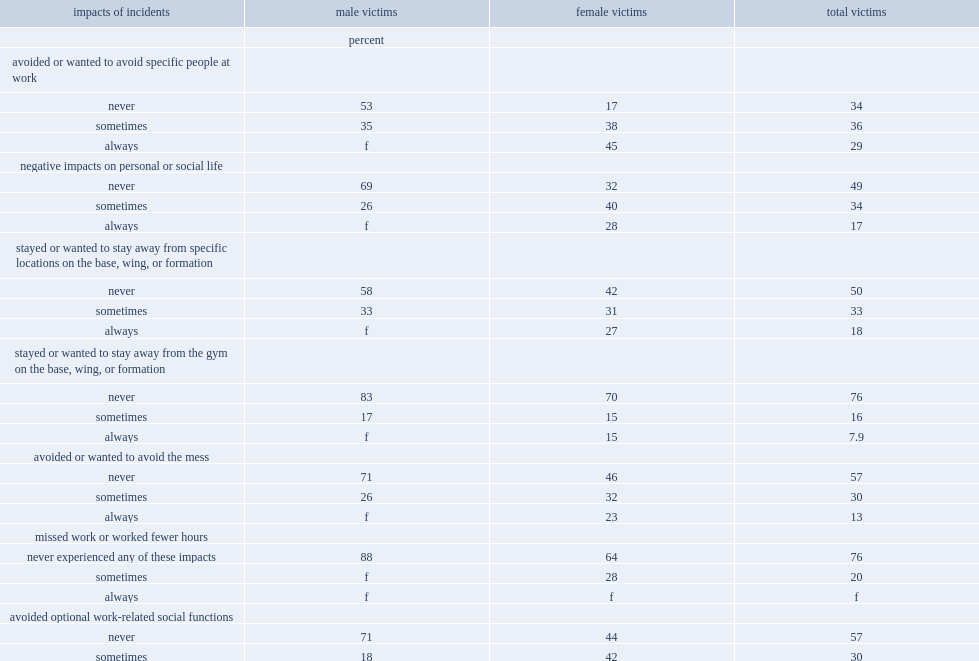What percentage of victims reported that they always wanted to avoid specific people at work as a result of being sexually assaulted? 29.0. What percentage of victims always experienced negative emotional impacts, including depression, anxiety, fear or anger because of the sexual assault? 21.0. Victims of which gender were considerably more likely to have sometimes avoided optional work-related social functions, male or female? Female victims. What percentage of reservists who had been sexually assaulted reported that they never experienced any of these impacts as a result? 22.0. What percentage of male reservists who had been sexually assaulted reported never having experiencing any of the impacts listed above? 36.0. 